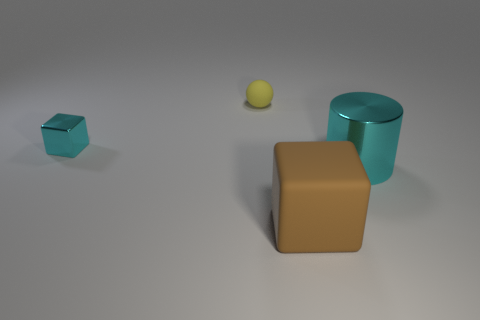Add 4 large brown things. How many objects exist? 8 Subtract all cylinders. How many objects are left? 3 Subtract 0 red balls. How many objects are left? 4 Subtract all large brown matte things. Subtract all large brown cubes. How many objects are left? 2 Add 1 big brown objects. How many big brown objects are left? 2 Add 1 blue metal things. How many blue metal things exist? 1 